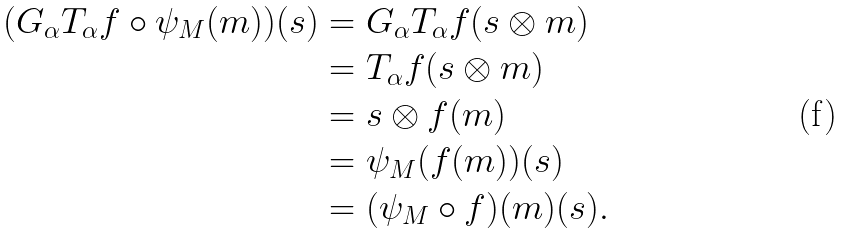<formula> <loc_0><loc_0><loc_500><loc_500>( G _ { \alpha } T _ { \alpha } f \circ \psi _ { M } ( m ) ) ( s ) & = G _ { \alpha } T _ { \alpha } f ( s \otimes m ) \\ & = T _ { \alpha } f ( s \otimes m ) \\ & = s \otimes f ( m ) \\ & = \psi _ { M } ( f ( m ) ) ( s ) \\ & = ( \psi _ { M } \circ f ) ( m ) ( s ) .</formula> 